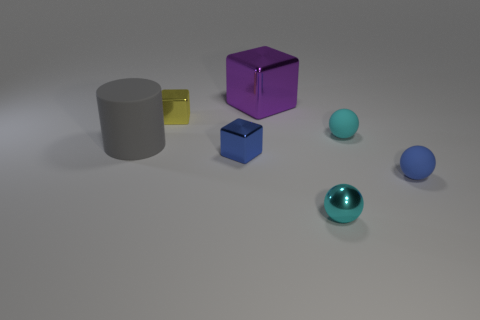How many objects are small blue metal things that are behind the blue rubber ball or tiny cyan metal spheres?
Offer a very short reply. 2. What is the shape of the tiny blue object that is the same material as the large block?
Offer a terse response. Cube. How many blue metallic objects are the same shape as the yellow thing?
Your answer should be very brief. 1. What material is the tiny yellow block?
Give a very brief answer. Metal. Does the big shiny block have the same color as the tiny shiny cube behind the big gray rubber thing?
Provide a succinct answer. No. How many blocks are small metal things or blue metal things?
Your answer should be very brief. 2. What color is the block behind the tiny yellow block?
Make the answer very short. Purple. The tiny rubber thing that is the same color as the small shiny ball is what shape?
Provide a succinct answer. Sphere. What number of cyan matte balls have the same size as the blue metallic object?
Ensure brevity in your answer.  1. Is the shape of the tiny cyan thing that is behind the tiny metallic sphere the same as the big thing in front of the tiny yellow shiny block?
Provide a succinct answer. No. 